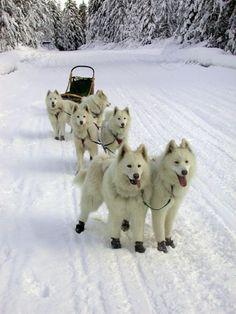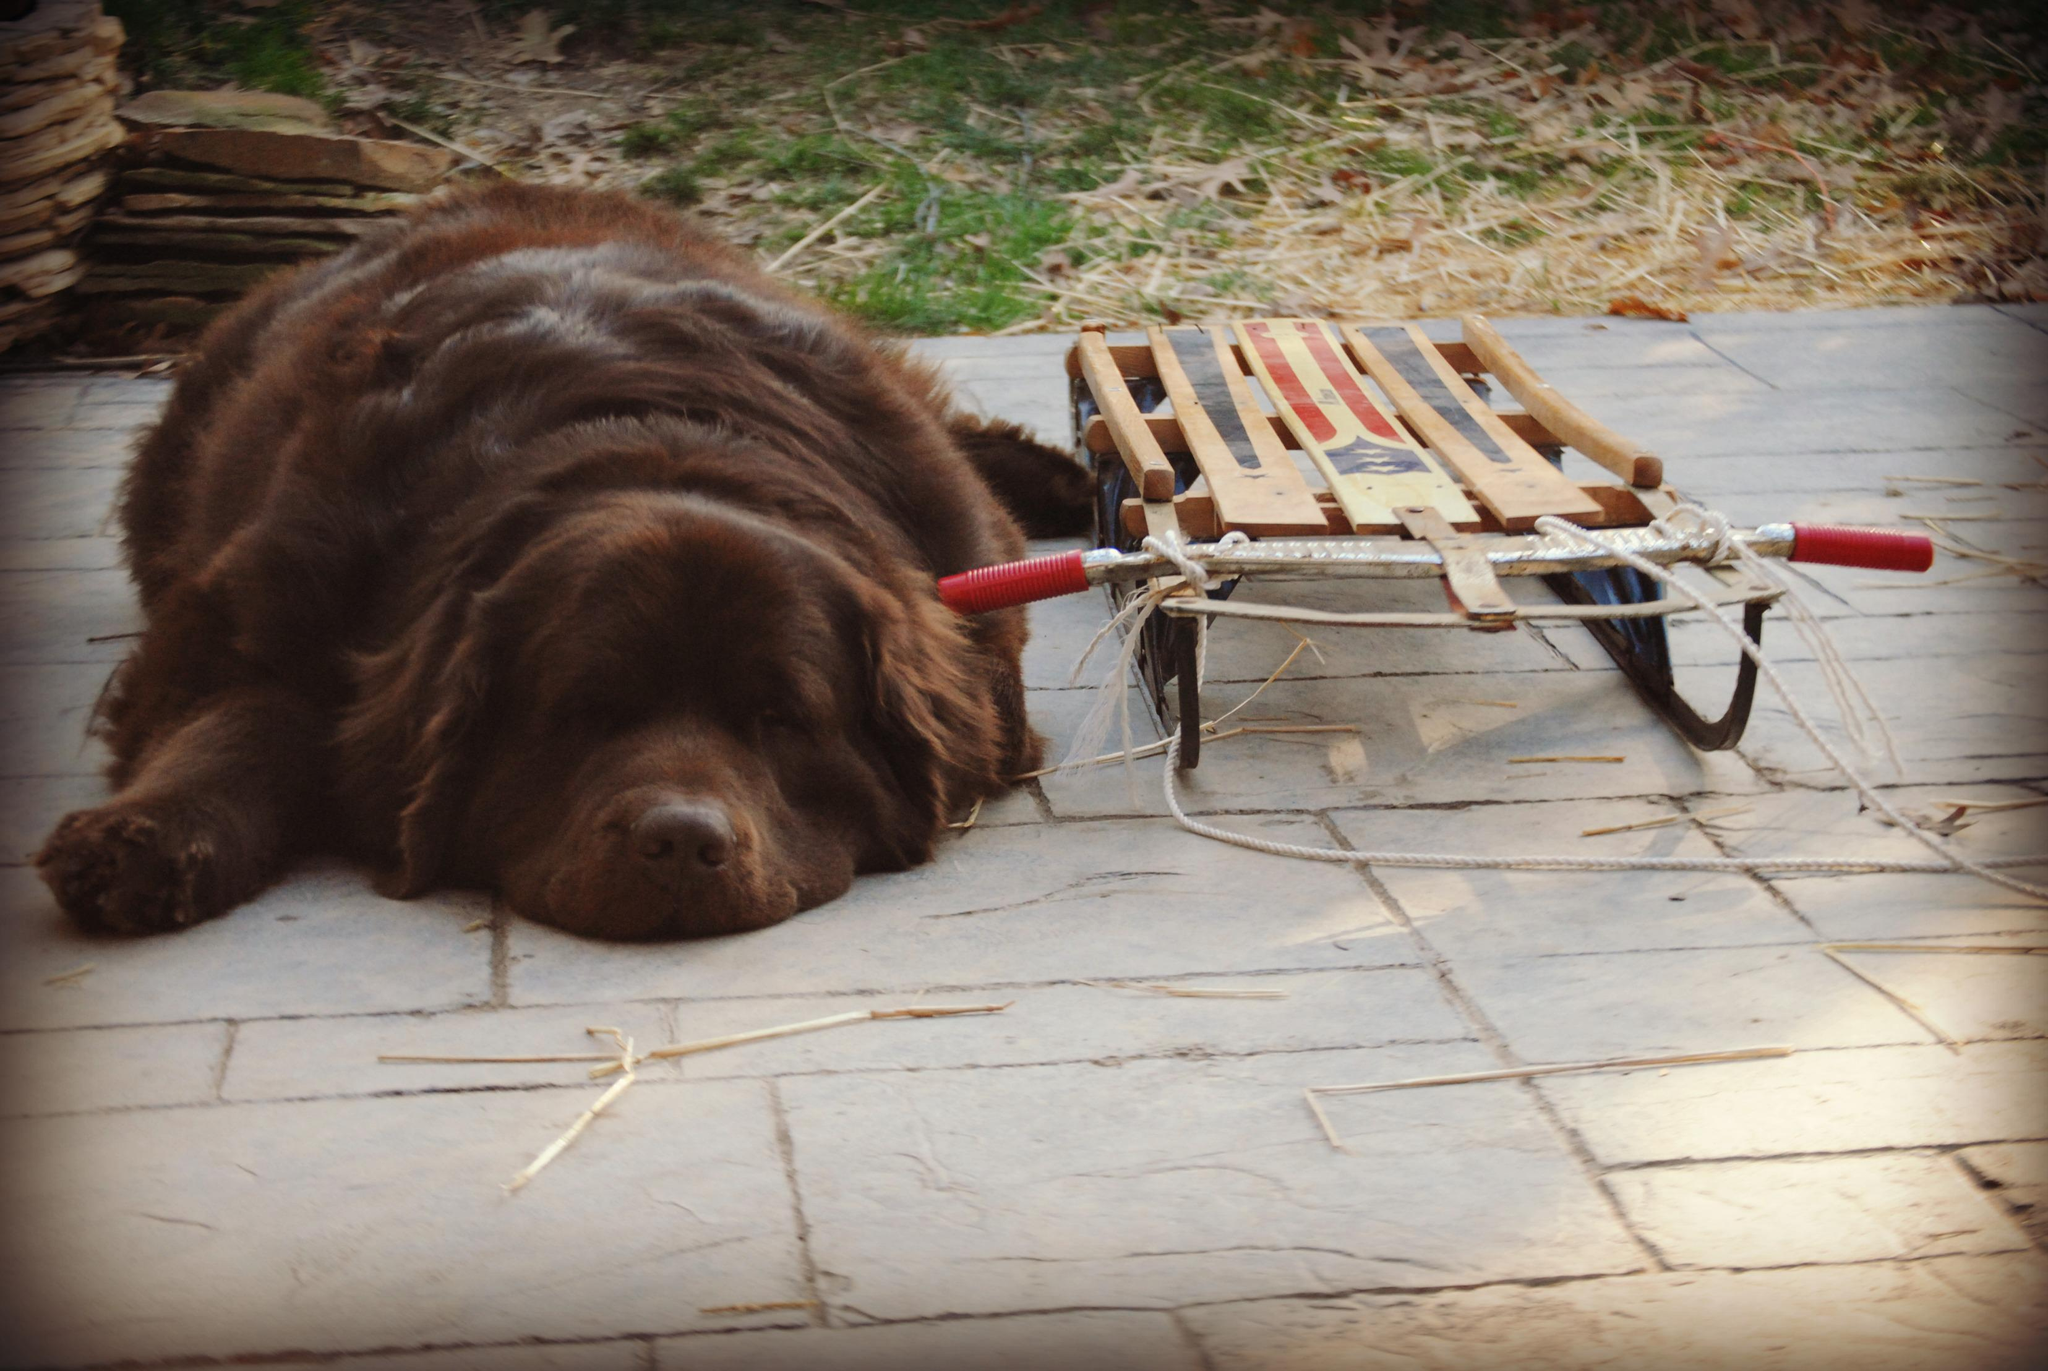The first image is the image on the left, the second image is the image on the right. Evaluate the accuracy of this statement regarding the images: "One image shows a team of dogs hitched to a sled, and the other image shows a brown, non-husky dog posed with a sled but not hitched to pull it.". Is it true? Answer yes or no. Yes. The first image is the image on the left, the second image is the image on the right. Examine the images to the left and right. Is the description "In only one of the two images are the dogs awake." accurate? Answer yes or no. Yes. 